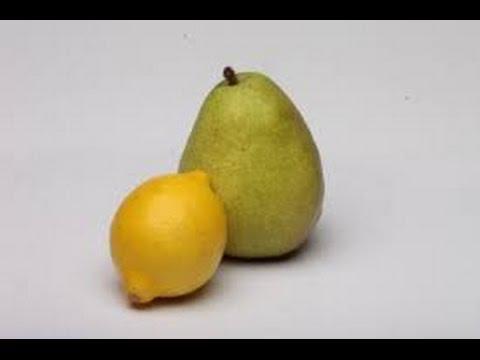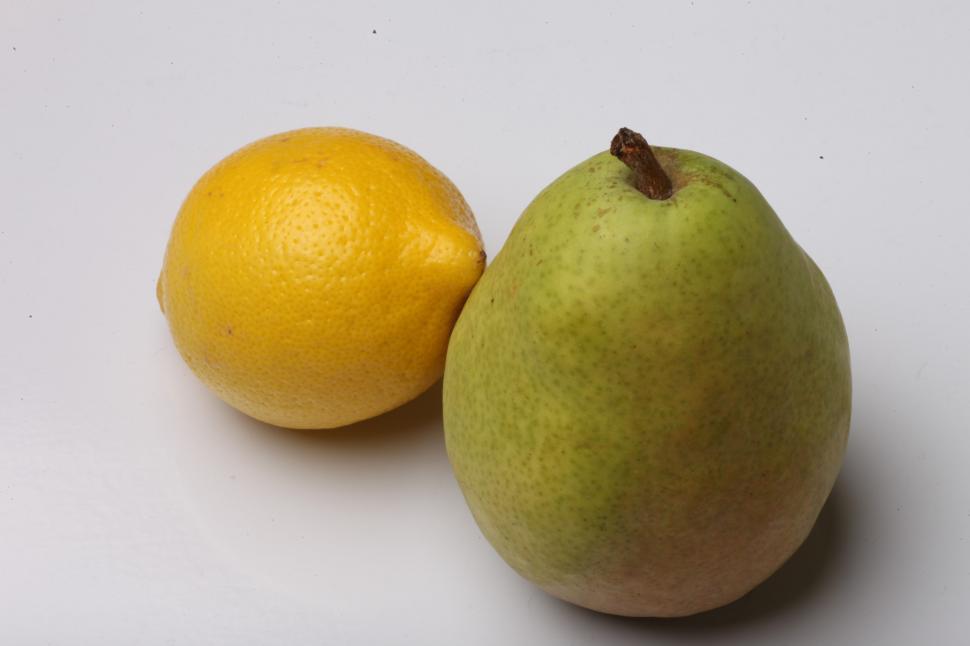The first image is the image on the left, the second image is the image on the right. Assess this claim about the two images: "In both images a lemon is in front of a pear.". Correct or not? Answer yes or no. No. 